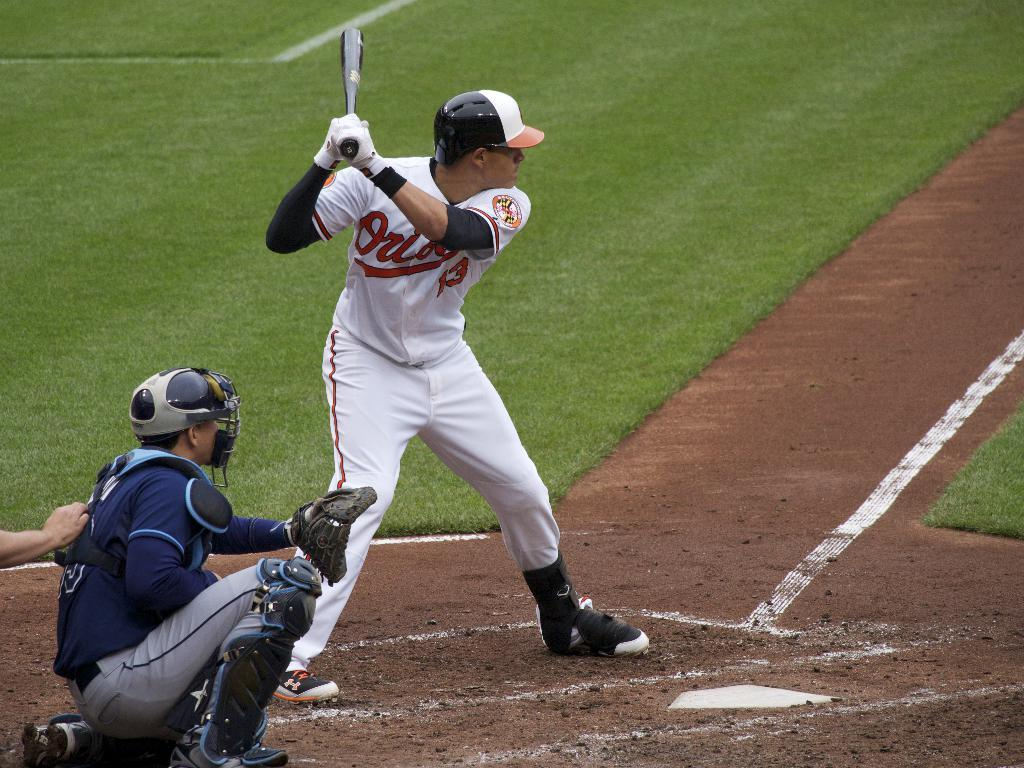<image>
Provide a brief description of the given image. the team name Orioles on a jersey someone has 